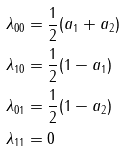<formula> <loc_0><loc_0><loc_500><loc_500>\lambda _ { 0 0 } & = \frac { 1 } { 2 } ( a _ { 1 } + a _ { 2 } ) \\ \lambda _ { 1 0 } & = \frac { 1 } { 2 } ( 1 - a _ { 1 } ) \\ \lambda _ { 0 1 } & = \frac { 1 } { 2 } ( 1 - a _ { 2 } ) \\ \lambda _ { 1 1 } & = 0</formula> 